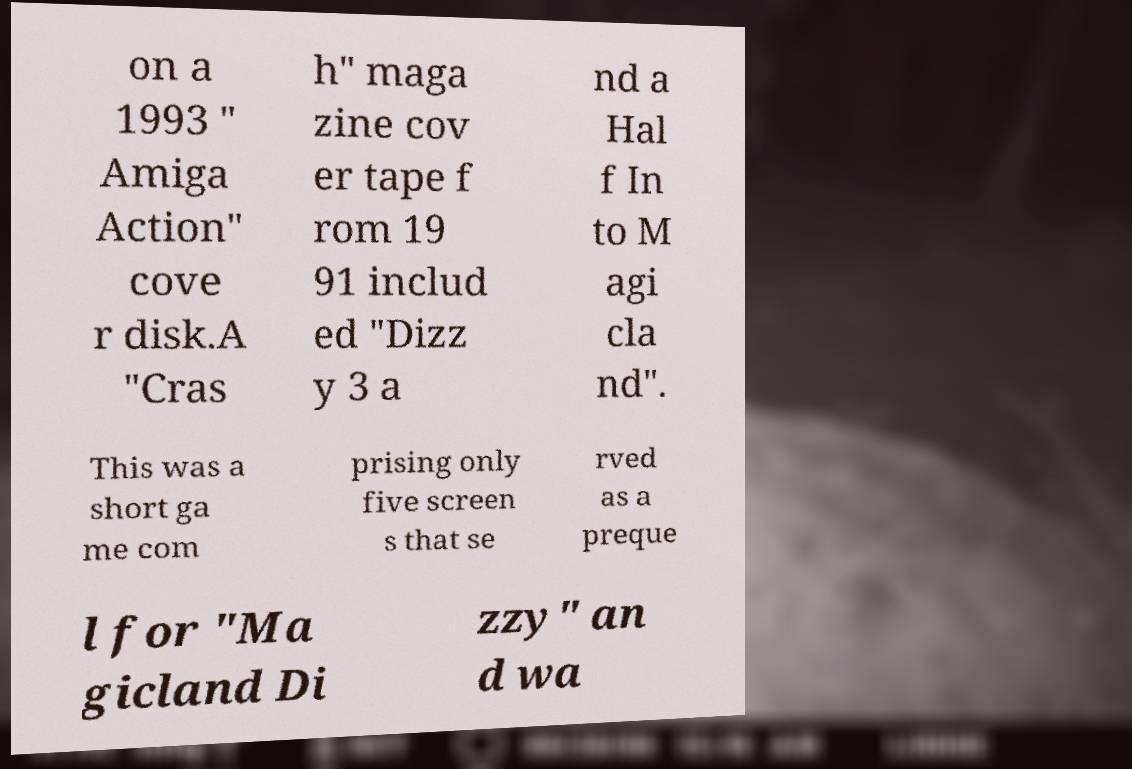Can you accurately transcribe the text from the provided image for me? on a 1993 " Amiga Action" cove r disk.A "Cras h" maga zine cov er tape f rom 19 91 includ ed "Dizz y 3 a nd a Hal f In to M agi cla nd". This was a short ga me com prising only five screen s that se rved as a preque l for "Ma gicland Di zzy" an d wa 